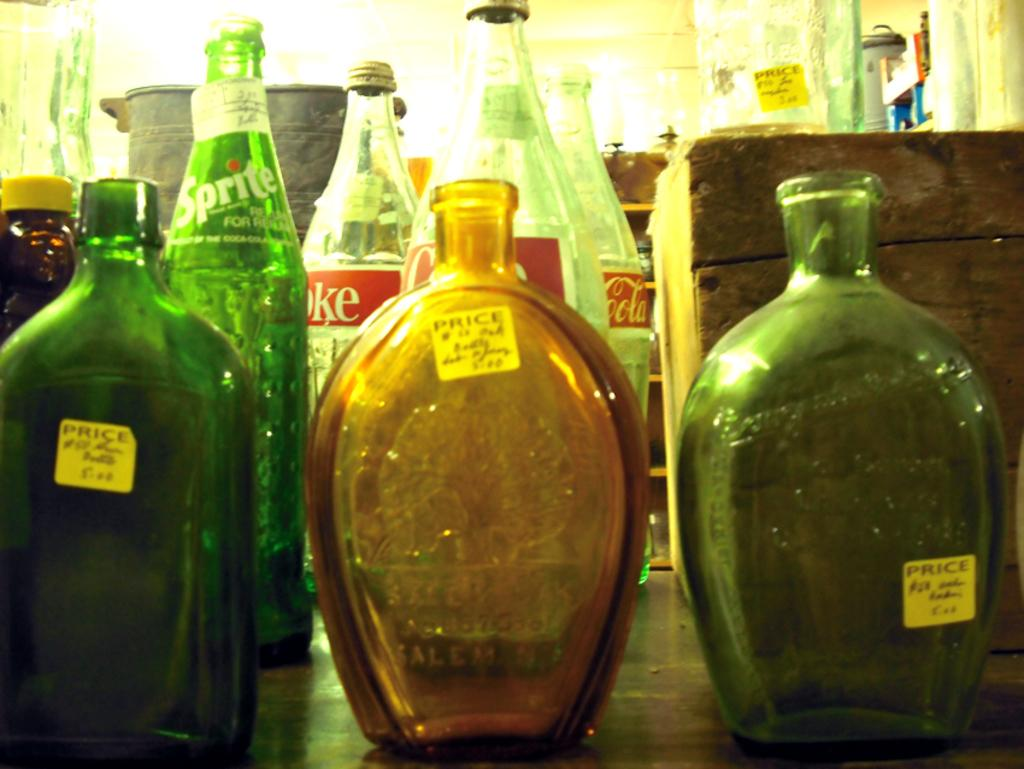<image>
Render a clear and concise summary of the photo. Various glass bottles with a yellow sticker on the sides that says Price. 